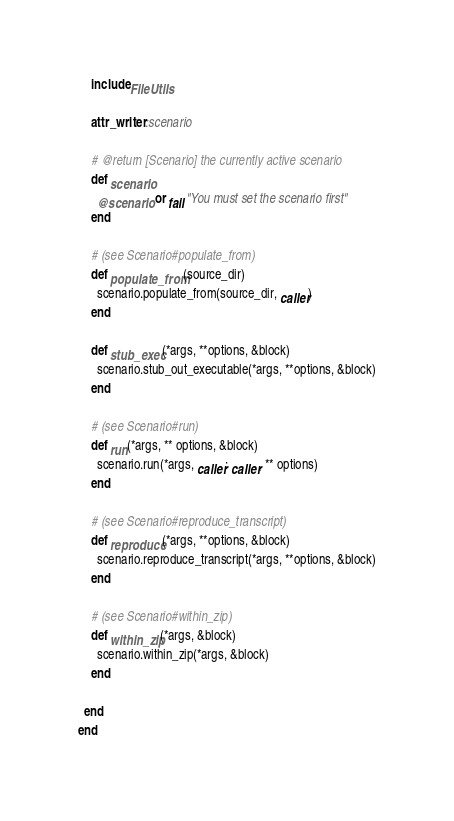Convert code to text. <code><loc_0><loc_0><loc_500><loc_500><_Ruby_>    include FileUtils

    attr_writer :scenario

    # @return [Scenario] the currently active scenario
    def scenario
      @scenario or fail "You must set the scenario first"
    end

    # (see Scenario#populate_from)
    def populate_from(source_dir)
      scenario.populate_from(source_dir, caller)
    end

    def stub_exec(*args, **options, &block)
      scenario.stub_out_executable(*args, **options, &block)
    end

    # (see Scenario#run)
    def run(*args, ** options, &block)
      scenario.run(*args, caller: caller, ** options)
    end

    # (see Scenario#reproduce_transcript)
    def reproduce(*args, **options, &block)
      scenario.reproduce_transcript(*args, **options, &block)
    end

    # (see Scenario#within_zip)
    def within_zip(*args, &block)
      scenario.within_zip(*args, &block)
    end

  end
end
</code> 